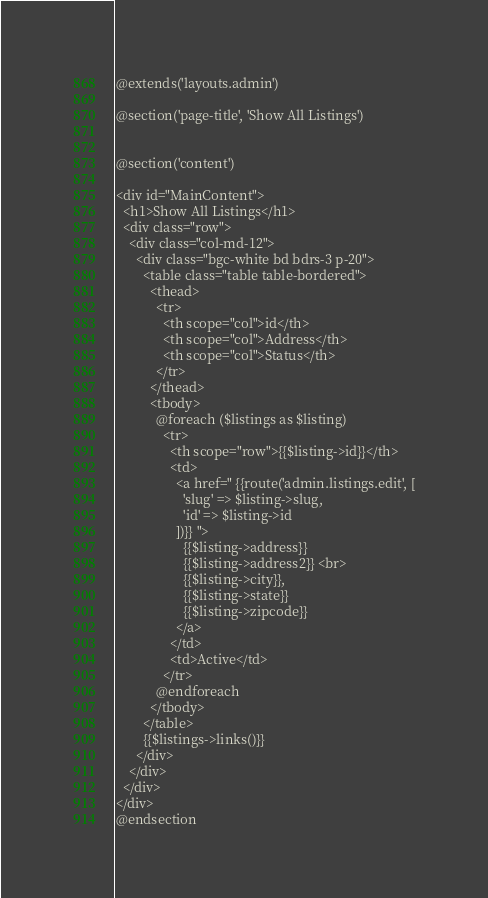Convert code to text. <code><loc_0><loc_0><loc_500><loc_500><_PHP_>@extends('layouts.admin')

@section('page-title', 'Show All Listings')


@section('content')

<div id="MainContent">
  <h1>Show All Listings</h1>
  <div class="row">
    <div class="col-md-12">
      <div class="bgc-white bd bdrs-3 p-20">
        <table class="table table-bordered">
          <thead>
            <tr>
              <th scope="col">id</th>
              <th scope="col">Address</th>
              <th scope="col">Status</th>
            </tr>
          </thead>
          <tbody>
            @foreach ($listings as $listing)
              <tr>
                <th scope="row">{{$listing->id}}</th>
                <td>
                  <a href=" {{route('admin.listings.edit', [
                    'slug' => $listing->slug,
                    'id' => $listing->id
                  ])}} ">
                    {{$listing->address}} 
                    {{$listing->address2}} <br>
                    {{$listing->city}}, 
                    {{$listing->state}} 
                    {{$listing->zipcode}}
                  </a>
                </td>
                <td>Active</td>
              </tr>
            @endforeach
          </tbody>
        </table>
        {{$listings->links()}}
      </div>
    </div>
  </div>
</div>
@endsection</code> 